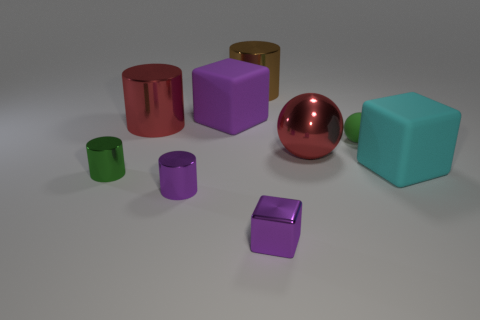Subtract all tiny purple cubes. How many cubes are left? 2 Add 1 small matte balls. How many objects exist? 10 Subtract all brown cylinders. How many cylinders are left? 3 Subtract 1 blocks. How many blocks are left? 2 Subtract all blue cylinders. Subtract all green cubes. How many cylinders are left? 4 Subtract all purple cubes. How many brown cylinders are left? 1 Subtract all large red shiny cylinders. Subtract all tiny balls. How many objects are left? 7 Add 1 green metal cylinders. How many green metal cylinders are left? 2 Add 9 small purple rubber things. How many small purple rubber things exist? 9 Subtract 0 blue balls. How many objects are left? 9 